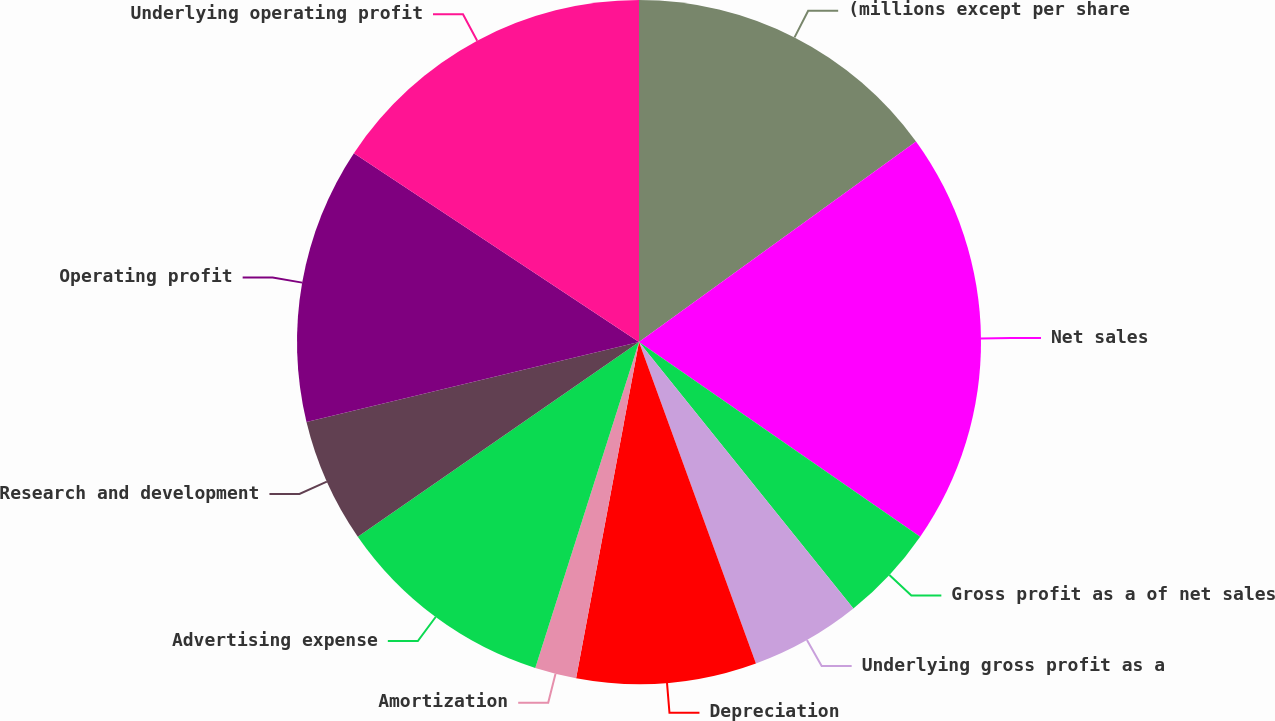Convert chart. <chart><loc_0><loc_0><loc_500><loc_500><pie_chart><fcel>(millions except per share<fcel>Net sales<fcel>Gross profit as a of net sales<fcel>Underlying gross profit as a<fcel>Depreciation<fcel>Amortization<fcel>Advertising expense<fcel>Research and development<fcel>Operating profit<fcel>Underlying operating profit<nl><fcel>15.03%<fcel>19.61%<fcel>4.58%<fcel>5.23%<fcel>8.5%<fcel>1.96%<fcel>10.46%<fcel>5.88%<fcel>13.07%<fcel>15.69%<nl></chart> 